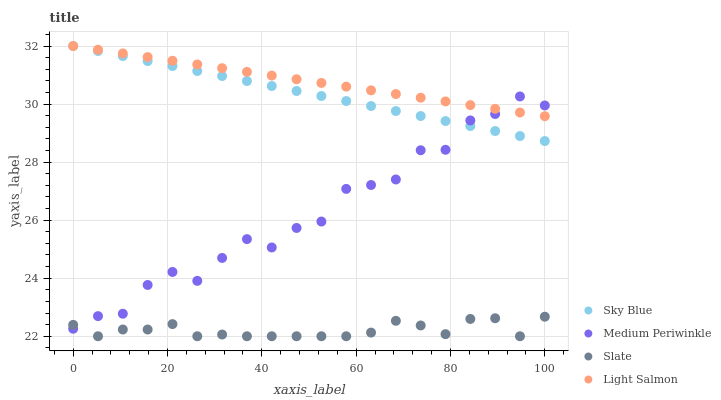Does Slate have the minimum area under the curve?
Answer yes or no. Yes. Does Light Salmon have the maximum area under the curve?
Answer yes or no. Yes. Does Medium Periwinkle have the minimum area under the curve?
Answer yes or no. No. Does Medium Periwinkle have the maximum area under the curve?
Answer yes or no. No. Is Light Salmon the smoothest?
Answer yes or no. Yes. Is Medium Periwinkle the roughest?
Answer yes or no. Yes. Is Slate the smoothest?
Answer yes or no. No. Is Slate the roughest?
Answer yes or no. No. Does Slate have the lowest value?
Answer yes or no. Yes. Does Medium Periwinkle have the lowest value?
Answer yes or no. No. Does Light Salmon have the highest value?
Answer yes or no. Yes. Does Medium Periwinkle have the highest value?
Answer yes or no. No. Is Slate less than Light Salmon?
Answer yes or no. Yes. Is Sky Blue greater than Slate?
Answer yes or no. Yes. Does Light Salmon intersect Sky Blue?
Answer yes or no. Yes. Is Light Salmon less than Sky Blue?
Answer yes or no. No. Is Light Salmon greater than Sky Blue?
Answer yes or no. No. Does Slate intersect Light Salmon?
Answer yes or no. No. 